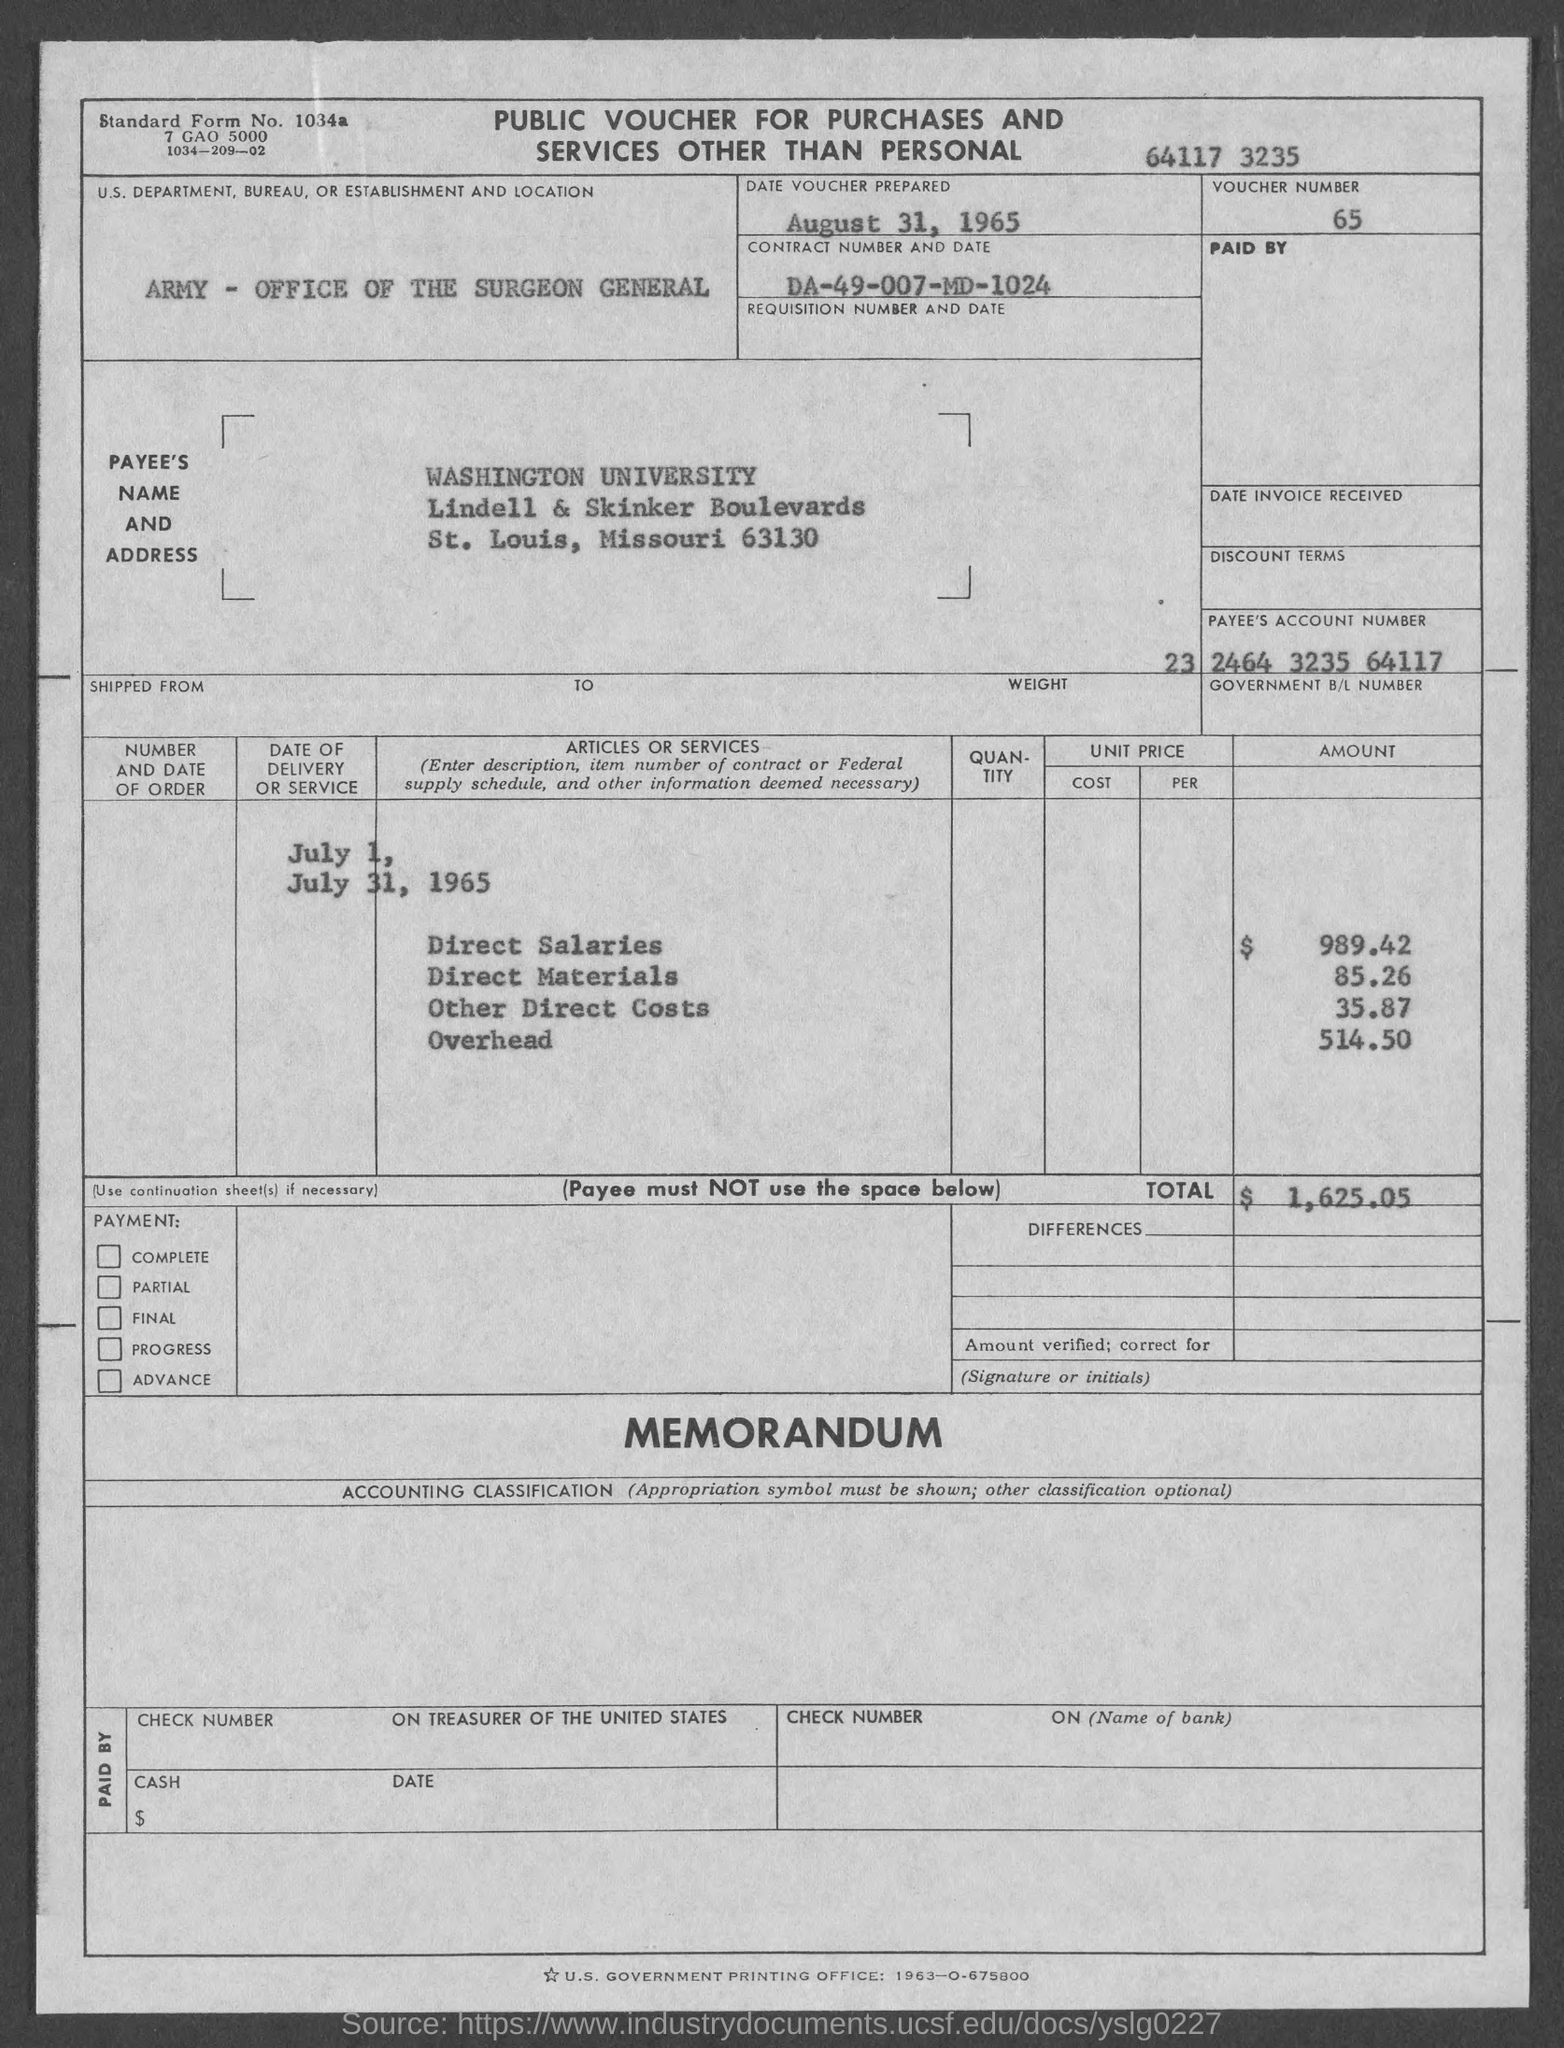Draw attention to some important aspects in this diagram. Can you please provide the payee's account number, which is 23 2464 3235 64117... The voucher was prepared on August 31, 1965. The voucher number is 65. The amount of direct materials is 85 and 26... The amount of direct salaries is $989.42. 